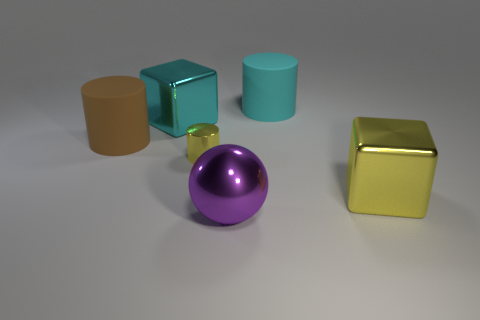Are there any things that have the same color as the tiny cylinder?
Offer a terse response. Yes. Are there any other things that have the same size as the metallic ball?
Provide a short and direct response. Yes. How many objects are either big brown rubber cylinders or large rubber cylinders on the right side of the tiny yellow cylinder?
Offer a terse response. 2. The purple ball that is the same material as the small object is what size?
Ensure brevity in your answer.  Large. What shape is the thing that is in front of the block that is on the right side of the cyan cylinder?
Ensure brevity in your answer.  Sphere. There is a object that is right of the purple shiny sphere and on the left side of the yellow block; what is its size?
Ensure brevity in your answer.  Large. Is there a big brown metallic thing that has the same shape as the big cyan metallic thing?
Offer a terse response. No. Is there anything else that is the same shape as the tiny thing?
Give a very brief answer. Yes. There is a cyan thing that is in front of the large cyan rubber object that is behind the yellow metallic thing that is on the left side of the big purple thing; what is it made of?
Provide a short and direct response. Metal. Is there a green block that has the same size as the cyan cylinder?
Offer a terse response. No. 